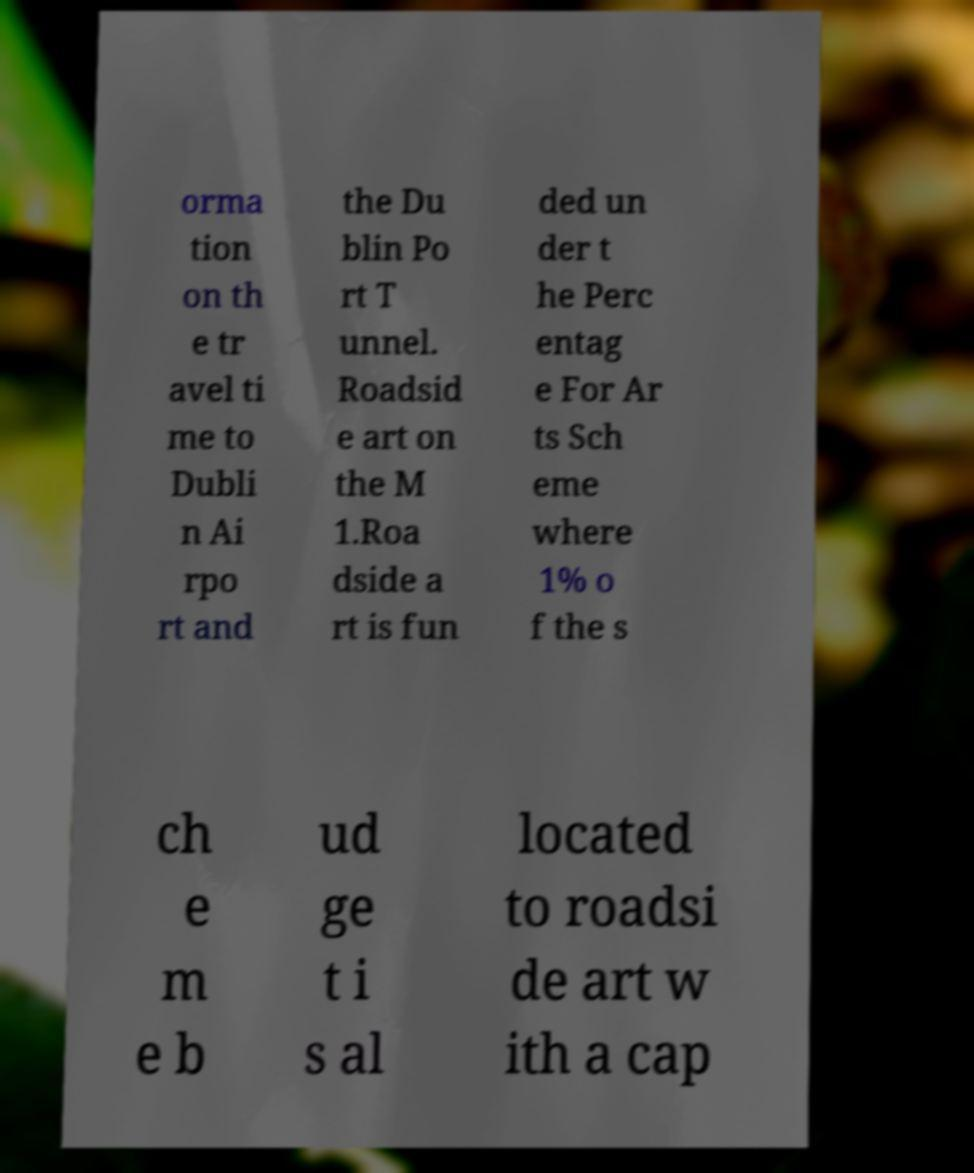Can you read and provide the text displayed in the image?This photo seems to have some interesting text. Can you extract and type it out for me? orma tion on th e tr avel ti me to Dubli n Ai rpo rt and the Du blin Po rt T unnel. Roadsid e art on the M 1.Roa dside a rt is fun ded un der t he Perc entag e For Ar ts Sch eme where 1% o f the s ch e m e b ud ge t i s al located to roadsi de art w ith a cap 